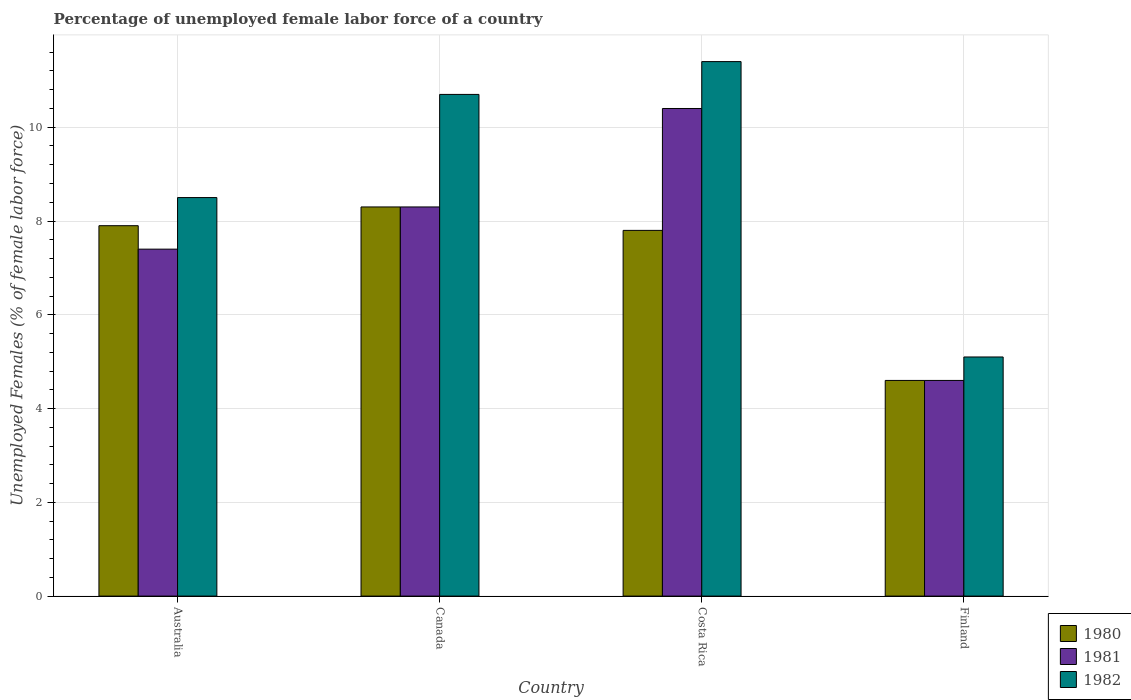Are the number of bars per tick equal to the number of legend labels?
Give a very brief answer. Yes. Are the number of bars on each tick of the X-axis equal?
Your answer should be compact. Yes. How many bars are there on the 4th tick from the left?
Make the answer very short. 3. What is the percentage of unemployed female labor force in 1982 in Finland?
Provide a succinct answer. 5.1. Across all countries, what is the maximum percentage of unemployed female labor force in 1980?
Offer a very short reply. 8.3. Across all countries, what is the minimum percentage of unemployed female labor force in 1982?
Provide a short and direct response. 5.1. What is the total percentage of unemployed female labor force in 1982 in the graph?
Offer a very short reply. 35.7. What is the difference between the percentage of unemployed female labor force in 1981 in Canada and that in Finland?
Offer a terse response. 3.7. What is the difference between the percentage of unemployed female labor force in 1981 in Finland and the percentage of unemployed female labor force in 1980 in Australia?
Make the answer very short. -3.3. What is the average percentage of unemployed female labor force in 1982 per country?
Keep it short and to the point. 8.92. What is the difference between the percentage of unemployed female labor force of/in 1980 and percentage of unemployed female labor force of/in 1982 in Costa Rica?
Make the answer very short. -3.6. What is the ratio of the percentage of unemployed female labor force in 1982 in Australia to that in Canada?
Offer a very short reply. 0.79. Is the difference between the percentage of unemployed female labor force in 1980 in Australia and Costa Rica greater than the difference between the percentage of unemployed female labor force in 1982 in Australia and Costa Rica?
Give a very brief answer. Yes. What is the difference between the highest and the second highest percentage of unemployed female labor force in 1982?
Give a very brief answer. -2.2. What is the difference between the highest and the lowest percentage of unemployed female labor force in 1981?
Offer a very short reply. 5.8. In how many countries, is the percentage of unemployed female labor force in 1982 greater than the average percentage of unemployed female labor force in 1982 taken over all countries?
Make the answer very short. 2. What does the 1st bar from the left in Finland represents?
Your answer should be very brief. 1980. Is it the case that in every country, the sum of the percentage of unemployed female labor force in 1981 and percentage of unemployed female labor force in 1980 is greater than the percentage of unemployed female labor force in 1982?
Give a very brief answer. Yes. How many countries are there in the graph?
Offer a terse response. 4. Are the values on the major ticks of Y-axis written in scientific E-notation?
Make the answer very short. No. Does the graph contain any zero values?
Offer a terse response. No. How many legend labels are there?
Your answer should be compact. 3. How are the legend labels stacked?
Your answer should be compact. Vertical. What is the title of the graph?
Your response must be concise. Percentage of unemployed female labor force of a country. What is the label or title of the Y-axis?
Provide a short and direct response. Unemployed Females (% of female labor force). What is the Unemployed Females (% of female labor force) in 1980 in Australia?
Keep it short and to the point. 7.9. What is the Unemployed Females (% of female labor force) in 1981 in Australia?
Provide a short and direct response. 7.4. What is the Unemployed Females (% of female labor force) of 1980 in Canada?
Provide a succinct answer. 8.3. What is the Unemployed Females (% of female labor force) of 1981 in Canada?
Offer a terse response. 8.3. What is the Unemployed Females (% of female labor force) of 1982 in Canada?
Keep it short and to the point. 10.7. What is the Unemployed Females (% of female labor force) in 1980 in Costa Rica?
Your answer should be compact. 7.8. What is the Unemployed Females (% of female labor force) in 1981 in Costa Rica?
Your answer should be very brief. 10.4. What is the Unemployed Females (% of female labor force) of 1982 in Costa Rica?
Your response must be concise. 11.4. What is the Unemployed Females (% of female labor force) of 1980 in Finland?
Provide a short and direct response. 4.6. What is the Unemployed Females (% of female labor force) in 1981 in Finland?
Make the answer very short. 4.6. What is the Unemployed Females (% of female labor force) in 1982 in Finland?
Make the answer very short. 5.1. Across all countries, what is the maximum Unemployed Females (% of female labor force) of 1980?
Offer a terse response. 8.3. Across all countries, what is the maximum Unemployed Females (% of female labor force) in 1981?
Offer a very short reply. 10.4. Across all countries, what is the maximum Unemployed Females (% of female labor force) of 1982?
Your answer should be very brief. 11.4. Across all countries, what is the minimum Unemployed Females (% of female labor force) in 1980?
Your answer should be compact. 4.6. Across all countries, what is the minimum Unemployed Females (% of female labor force) in 1981?
Provide a short and direct response. 4.6. Across all countries, what is the minimum Unemployed Females (% of female labor force) of 1982?
Provide a short and direct response. 5.1. What is the total Unemployed Females (% of female labor force) in 1980 in the graph?
Ensure brevity in your answer.  28.6. What is the total Unemployed Females (% of female labor force) of 1981 in the graph?
Offer a very short reply. 30.7. What is the total Unemployed Females (% of female labor force) in 1982 in the graph?
Your answer should be compact. 35.7. What is the difference between the Unemployed Females (% of female labor force) in 1980 in Australia and that in Canada?
Offer a very short reply. -0.4. What is the difference between the Unemployed Females (% of female labor force) of 1981 in Australia and that in Canada?
Your response must be concise. -0.9. What is the difference between the Unemployed Females (% of female labor force) in 1980 in Australia and that in Costa Rica?
Your answer should be very brief. 0.1. What is the difference between the Unemployed Females (% of female labor force) in 1981 in Australia and that in Costa Rica?
Keep it short and to the point. -3. What is the difference between the Unemployed Females (% of female labor force) of 1982 in Australia and that in Costa Rica?
Your answer should be very brief. -2.9. What is the difference between the Unemployed Females (% of female labor force) in 1980 in Australia and that in Finland?
Ensure brevity in your answer.  3.3. What is the difference between the Unemployed Females (% of female labor force) of 1982 in Australia and that in Finland?
Keep it short and to the point. 3.4. What is the difference between the Unemployed Females (% of female labor force) of 1980 in Canada and that in Costa Rica?
Offer a terse response. 0.5. What is the difference between the Unemployed Females (% of female labor force) in 1981 in Canada and that in Costa Rica?
Your answer should be compact. -2.1. What is the difference between the Unemployed Females (% of female labor force) of 1982 in Canada and that in Costa Rica?
Your response must be concise. -0.7. What is the difference between the Unemployed Females (% of female labor force) in 1981 in Canada and that in Finland?
Provide a short and direct response. 3.7. What is the difference between the Unemployed Females (% of female labor force) of 1980 in Costa Rica and that in Finland?
Keep it short and to the point. 3.2. What is the difference between the Unemployed Females (% of female labor force) in 1980 in Australia and the Unemployed Females (% of female labor force) in 1981 in Canada?
Provide a succinct answer. -0.4. What is the difference between the Unemployed Females (% of female labor force) in 1980 in Australia and the Unemployed Females (% of female labor force) in 1982 in Canada?
Keep it short and to the point. -2.8. What is the difference between the Unemployed Females (% of female labor force) of 1981 in Australia and the Unemployed Females (% of female labor force) of 1982 in Canada?
Give a very brief answer. -3.3. What is the difference between the Unemployed Females (% of female labor force) in 1981 in Australia and the Unemployed Females (% of female labor force) in 1982 in Costa Rica?
Your answer should be compact. -4. What is the difference between the Unemployed Females (% of female labor force) of 1980 in Australia and the Unemployed Females (% of female labor force) of 1981 in Finland?
Your answer should be compact. 3.3. What is the difference between the Unemployed Females (% of female labor force) in 1980 in Australia and the Unemployed Females (% of female labor force) in 1982 in Finland?
Give a very brief answer. 2.8. What is the difference between the Unemployed Females (% of female labor force) of 1981 in Canada and the Unemployed Females (% of female labor force) of 1982 in Costa Rica?
Offer a terse response. -3.1. What is the difference between the Unemployed Females (% of female labor force) of 1980 in Canada and the Unemployed Females (% of female labor force) of 1982 in Finland?
Offer a terse response. 3.2. What is the difference between the Unemployed Females (% of female labor force) of 1980 in Costa Rica and the Unemployed Females (% of female labor force) of 1982 in Finland?
Provide a short and direct response. 2.7. What is the average Unemployed Females (% of female labor force) in 1980 per country?
Offer a terse response. 7.15. What is the average Unemployed Females (% of female labor force) in 1981 per country?
Offer a terse response. 7.67. What is the average Unemployed Females (% of female labor force) in 1982 per country?
Ensure brevity in your answer.  8.93. What is the difference between the Unemployed Females (% of female labor force) of 1980 and Unemployed Females (% of female labor force) of 1982 in Australia?
Provide a succinct answer. -0.6. What is the difference between the Unemployed Females (% of female labor force) in 1980 and Unemployed Females (% of female labor force) in 1982 in Canada?
Provide a succinct answer. -2.4. What is the difference between the Unemployed Females (% of female labor force) of 1981 and Unemployed Females (% of female labor force) of 1982 in Canada?
Offer a terse response. -2.4. What is the difference between the Unemployed Females (% of female labor force) of 1980 and Unemployed Females (% of female labor force) of 1981 in Finland?
Make the answer very short. 0. What is the difference between the Unemployed Females (% of female labor force) of 1980 and Unemployed Females (% of female labor force) of 1982 in Finland?
Offer a very short reply. -0.5. What is the difference between the Unemployed Females (% of female labor force) in 1981 and Unemployed Females (% of female labor force) in 1982 in Finland?
Offer a very short reply. -0.5. What is the ratio of the Unemployed Females (% of female labor force) in 1980 in Australia to that in Canada?
Offer a terse response. 0.95. What is the ratio of the Unemployed Females (% of female labor force) of 1981 in Australia to that in Canada?
Make the answer very short. 0.89. What is the ratio of the Unemployed Females (% of female labor force) of 1982 in Australia to that in Canada?
Your answer should be very brief. 0.79. What is the ratio of the Unemployed Females (% of female labor force) in 1980 in Australia to that in Costa Rica?
Your response must be concise. 1.01. What is the ratio of the Unemployed Females (% of female labor force) in 1981 in Australia to that in Costa Rica?
Your response must be concise. 0.71. What is the ratio of the Unemployed Females (% of female labor force) of 1982 in Australia to that in Costa Rica?
Provide a short and direct response. 0.75. What is the ratio of the Unemployed Females (% of female labor force) of 1980 in Australia to that in Finland?
Keep it short and to the point. 1.72. What is the ratio of the Unemployed Females (% of female labor force) of 1981 in Australia to that in Finland?
Your answer should be very brief. 1.61. What is the ratio of the Unemployed Females (% of female labor force) in 1982 in Australia to that in Finland?
Your answer should be compact. 1.67. What is the ratio of the Unemployed Females (% of female labor force) in 1980 in Canada to that in Costa Rica?
Keep it short and to the point. 1.06. What is the ratio of the Unemployed Females (% of female labor force) of 1981 in Canada to that in Costa Rica?
Your answer should be compact. 0.8. What is the ratio of the Unemployed Females (% of female labor force) of 1982 in Canada to that in Costa Rica?
Your response must be concise. 0.94. What is the ratio of the Unemployed Females (% of female labor force) of 1980 in Canada to that in Finland?
Give a very brief answer. 1.8. What is the ratio of the Unemployed Females (% of female labor force) of 1981 in Canada to that in Finland?
Keep it short and to the point. 1.8. What is the ratio of the Unemployed Females (% of female labor force) in 1982 in Canada to that in Finland?
Make the answer very short. 2.1. What is the ratio of the Unemployed Females (% of female labor force) in 1980 in Costa Rica to that in Finland?
Make the answer very short. 1.7. What is the ratio of the Unemployed Females (% of female labor force) in 1981 in Costa Rica to that in Finland?
Your answer should be compact. 2.26. What is the ratio of the Unemployed Females (% of female labor force) in 1982 in Costa Rica to that in Finland?
Give a very brief answer. 2.24. What is the difference between the highest and the lowest Unemployed Females (% of female labor force) in 1982?
Your answer should be compact. 6.3. 